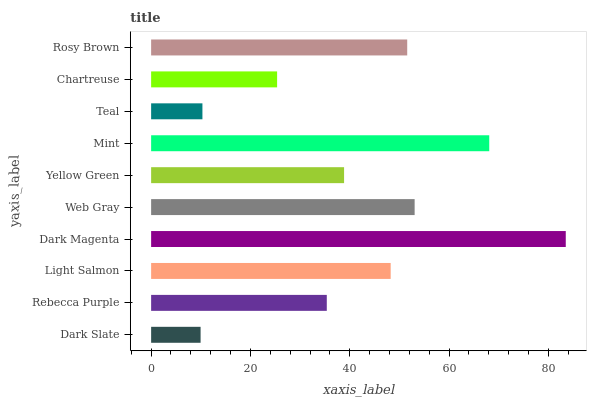Is Dark Slate the minimum?
Answer yes or no. Yes. Is Dark Magenta the maximum?
Answer yes or no. Yes. Is Rebecca Purple the minimum?
Answer yes or no. No. Is Rebecca Purple the maximum?
Answer yes or no. No. Is Rebecca Purple greater than Dark Slate?
Answer yes or no. Yes. Is Dark Slate less than Rebecca Purple?
Answer yes or no. Yes. Is Dark Slate greater than Rebecca Purple?
Answer yes or no. No. Is Rebecca Purple less than Dark Slate?
Answer yes or no. No. Is Light Salmon the high median?
Answer yes or no. Yes. Is Yellow Green the low median?
Answer yes or no. Yes. Is Teal the high median?
Answer yes or no. No. Is Web Gray the low median?
Answer yes or no. No. 